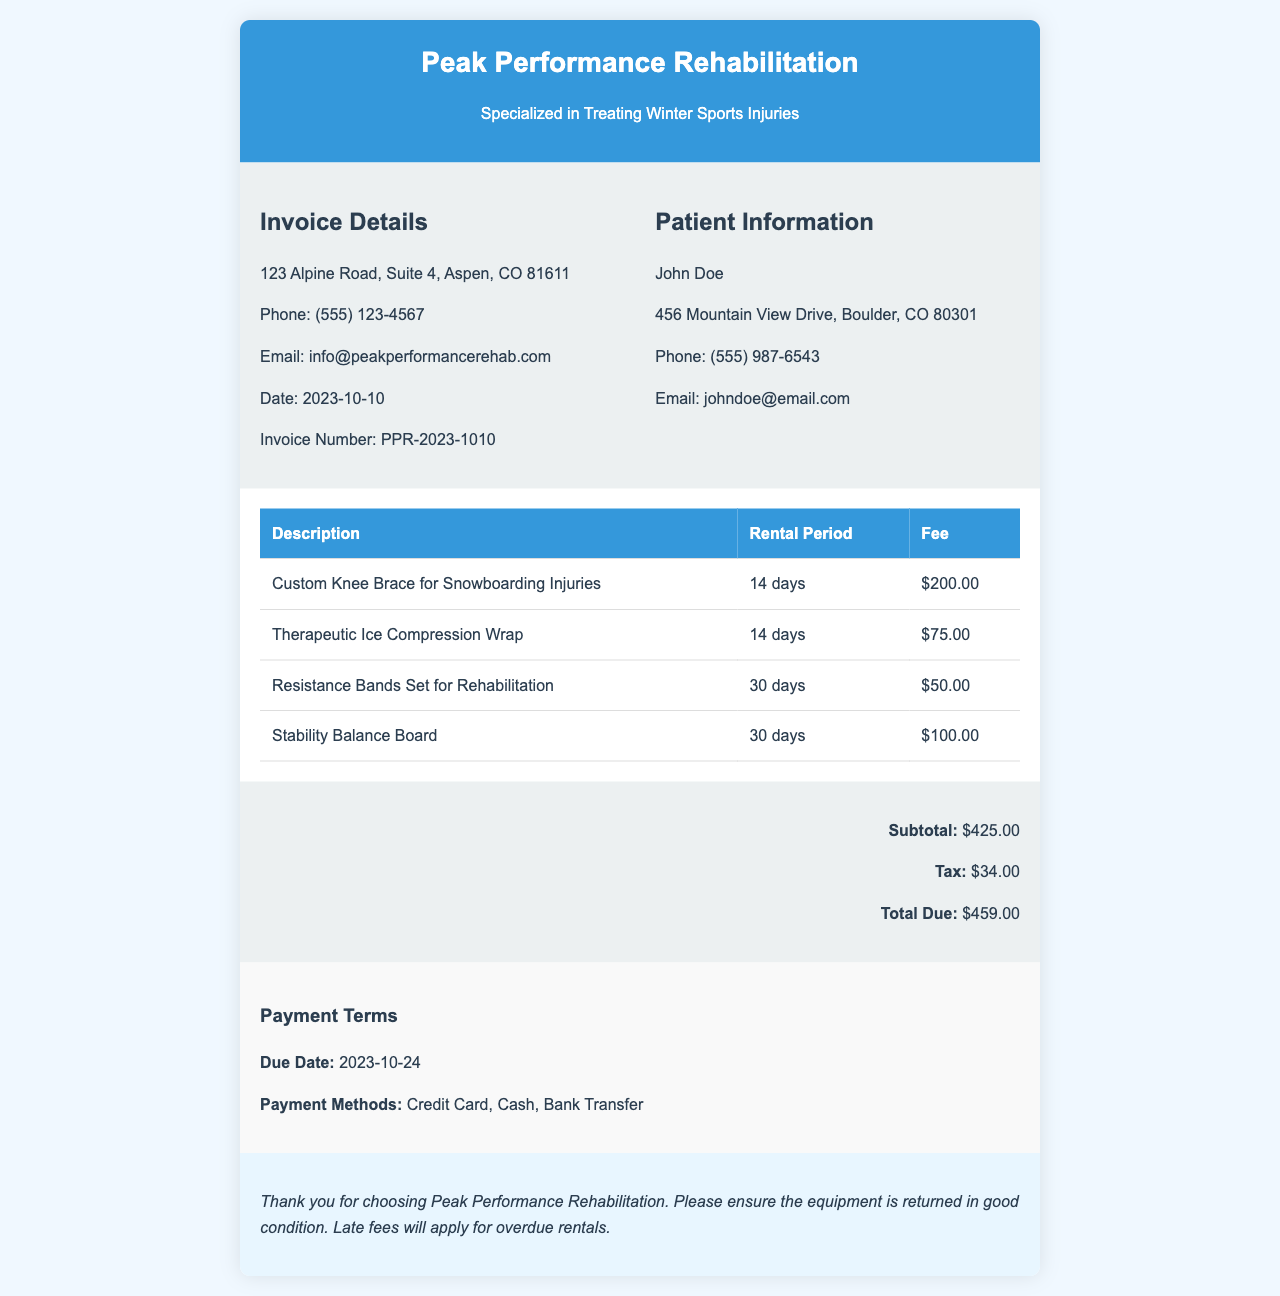What is the invoice number? The invoice number is specified in the document and is essential for tracking the invoice.
Answer: PPR-2023-1010 Who is the patient? The patient's name is listed in the document, identifying the individual receiving the services.
Answer: John Doe What is the due date for payment? The due date for the payment is clearly mentioned in the payment terms section of the document.
Answer: 2023-10-24 How much is the subtotal? The subtotal is the total before taxes are applied and is clearly stated in the total section of the document.
Answer: $425.00 What is the rental period for the Custom Knee Brace? The rental period for the specific item is provided in the invoice items section, detailing how long it can be rented.
Answer: 14 days What is the total amount due? The total due amount is the final figure that sums up the subtotal and tax, necessary for the patient to know.
Answer: $459.00 Which payment methods are accepted? The payment methods are listed under the payment terms, informing the patient of their options for making payment.
Answer: Credit Card, Cash, Bank Transfer How many items have a rental period of 30 days? The invoice details the rental period for each item, and this question checks for items with the longer rental duration.
Answer: 2 items What is the tax amount? The tax amount due is mentioned in the total section and is part of the financial summary of the invoice.
Answer: $34.00 